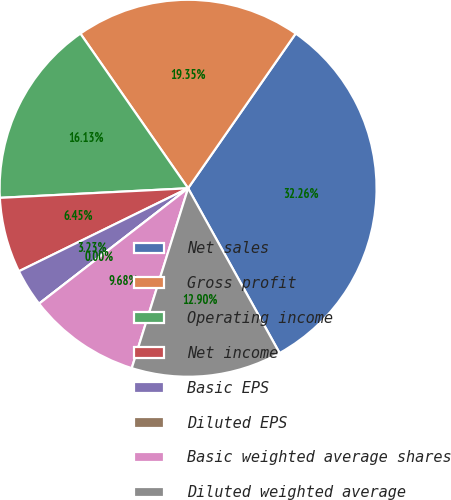<chart> <loc_0><loc_0><loc_500><loc_500><pie_chart><fcel>Net sales<fcel>Gross profit<fcel>Operating income<fcel>Net income<fcel>Basic EPS<fcel>Diluted EPS<fcel>Basic weighted average shares<fcel>Diluted weighted average<nl><fcel>32.26%<fcel>19.35%<fcel>16.13%<fcel>6.45%<fcel>3.23%<fcel>0.0%<fcel>9.68%<fcel>12.9%<nl></chart> 